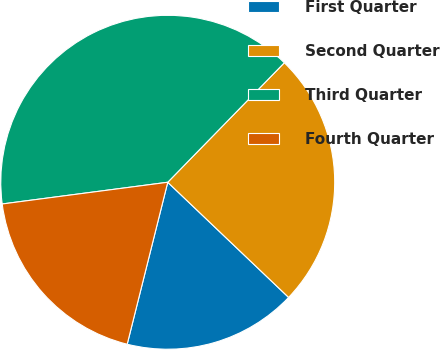<chart> <loc_0><loc_0><loc_500><loc_500><pie_chart><fcel>First Quarter<fcel>Second Quarter<fcel>Third Quarter<fcel>Fourth Quarter<nl><fcel>16.79%<fcel>24.81%<fcel>39.38%<fcel>19.02%<nl></chart> 